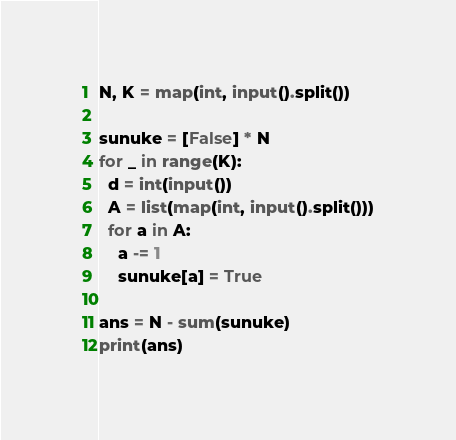<code> <loc_0><loc_0><loc_500><loc_500><_Python_>N, K = map(int, input().split())

sunuke = [False] * N
for _ in range(K):
  d = int(input())
  A = list(map(int, input().split()))
  for a in A:
    a -= 1
    sunuke[a] = True

ans = N - sum(sunuke)
print(ans)
</code> 